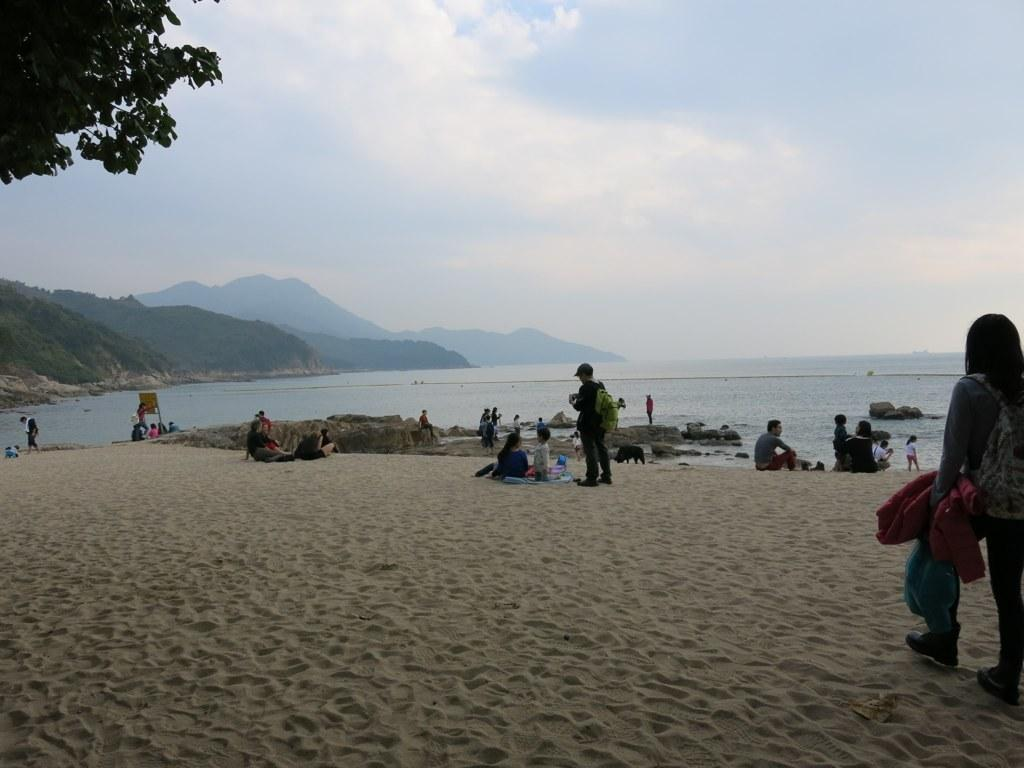What type of natural formation can be seen in the background of the image? There are mountains in the background of the image. What body of water is visible in the image? There is water visible in the image. What type of terrain is at the bottom of the image? There is sand at the bottom of the image. Can you describe the people in the image? There are people in the image. What type of vegetation is on the left side of the image? There are trees to the left side of the image. Where is the stamp located in the image? There is no stamp present in the image. What type of jail can be seen in the image? There is no jail present in the image. 